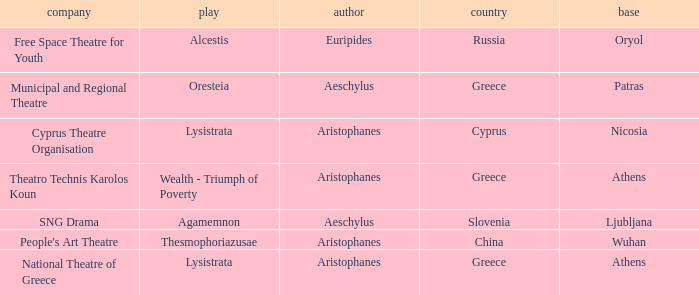What is the play when the company is cyprus theatre organisation? Lysistrata. 